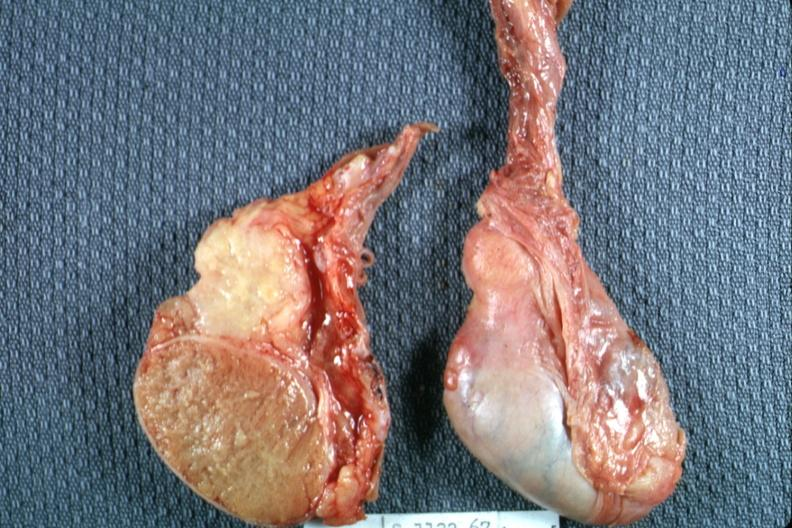what is present?
Answer the question using a single word or phrase. Tuberculosis 